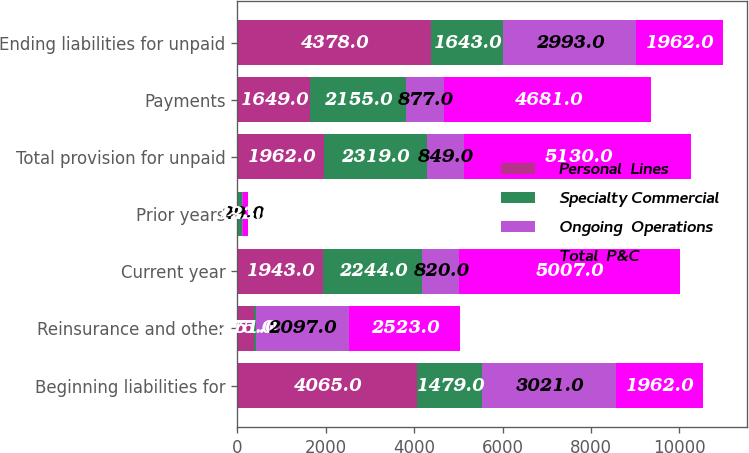<chart> <loc_0><loc_0><loc_500><loc_500><stacked_bar_chart><ecel><fcel>Beginning liabilities for<fcel>Reinsurance and other<fcel>Current year<fcel>Prior years<fcel>Total provision for unpaid<fcel>Payments<fcel>Ending liabilities for unpaid<nl><fcel>Personal  Lines<fcel>4065<fcel>375<fcel>1943<fcel>19<fcel>1962<fcel>1649<fcel>4378<nl><fcel>Specialty Commercial<fcel>1479<fcel>51<fcel>2244<fcel>75<fcel>2319<fcel>2155<fcel>1643<nl><fcel>Ongoing  Operations<fcel>3021<fcel>2097<fcel>820<fcel>29<fcel>849<fcel>877<fcel>2993<nl><fcel>Total  P&C<fcel>1962<fcel>2523<fcel>5007<fcel>123<fcel>5130<fcel>4681<fcel>1962<nl></chart> 